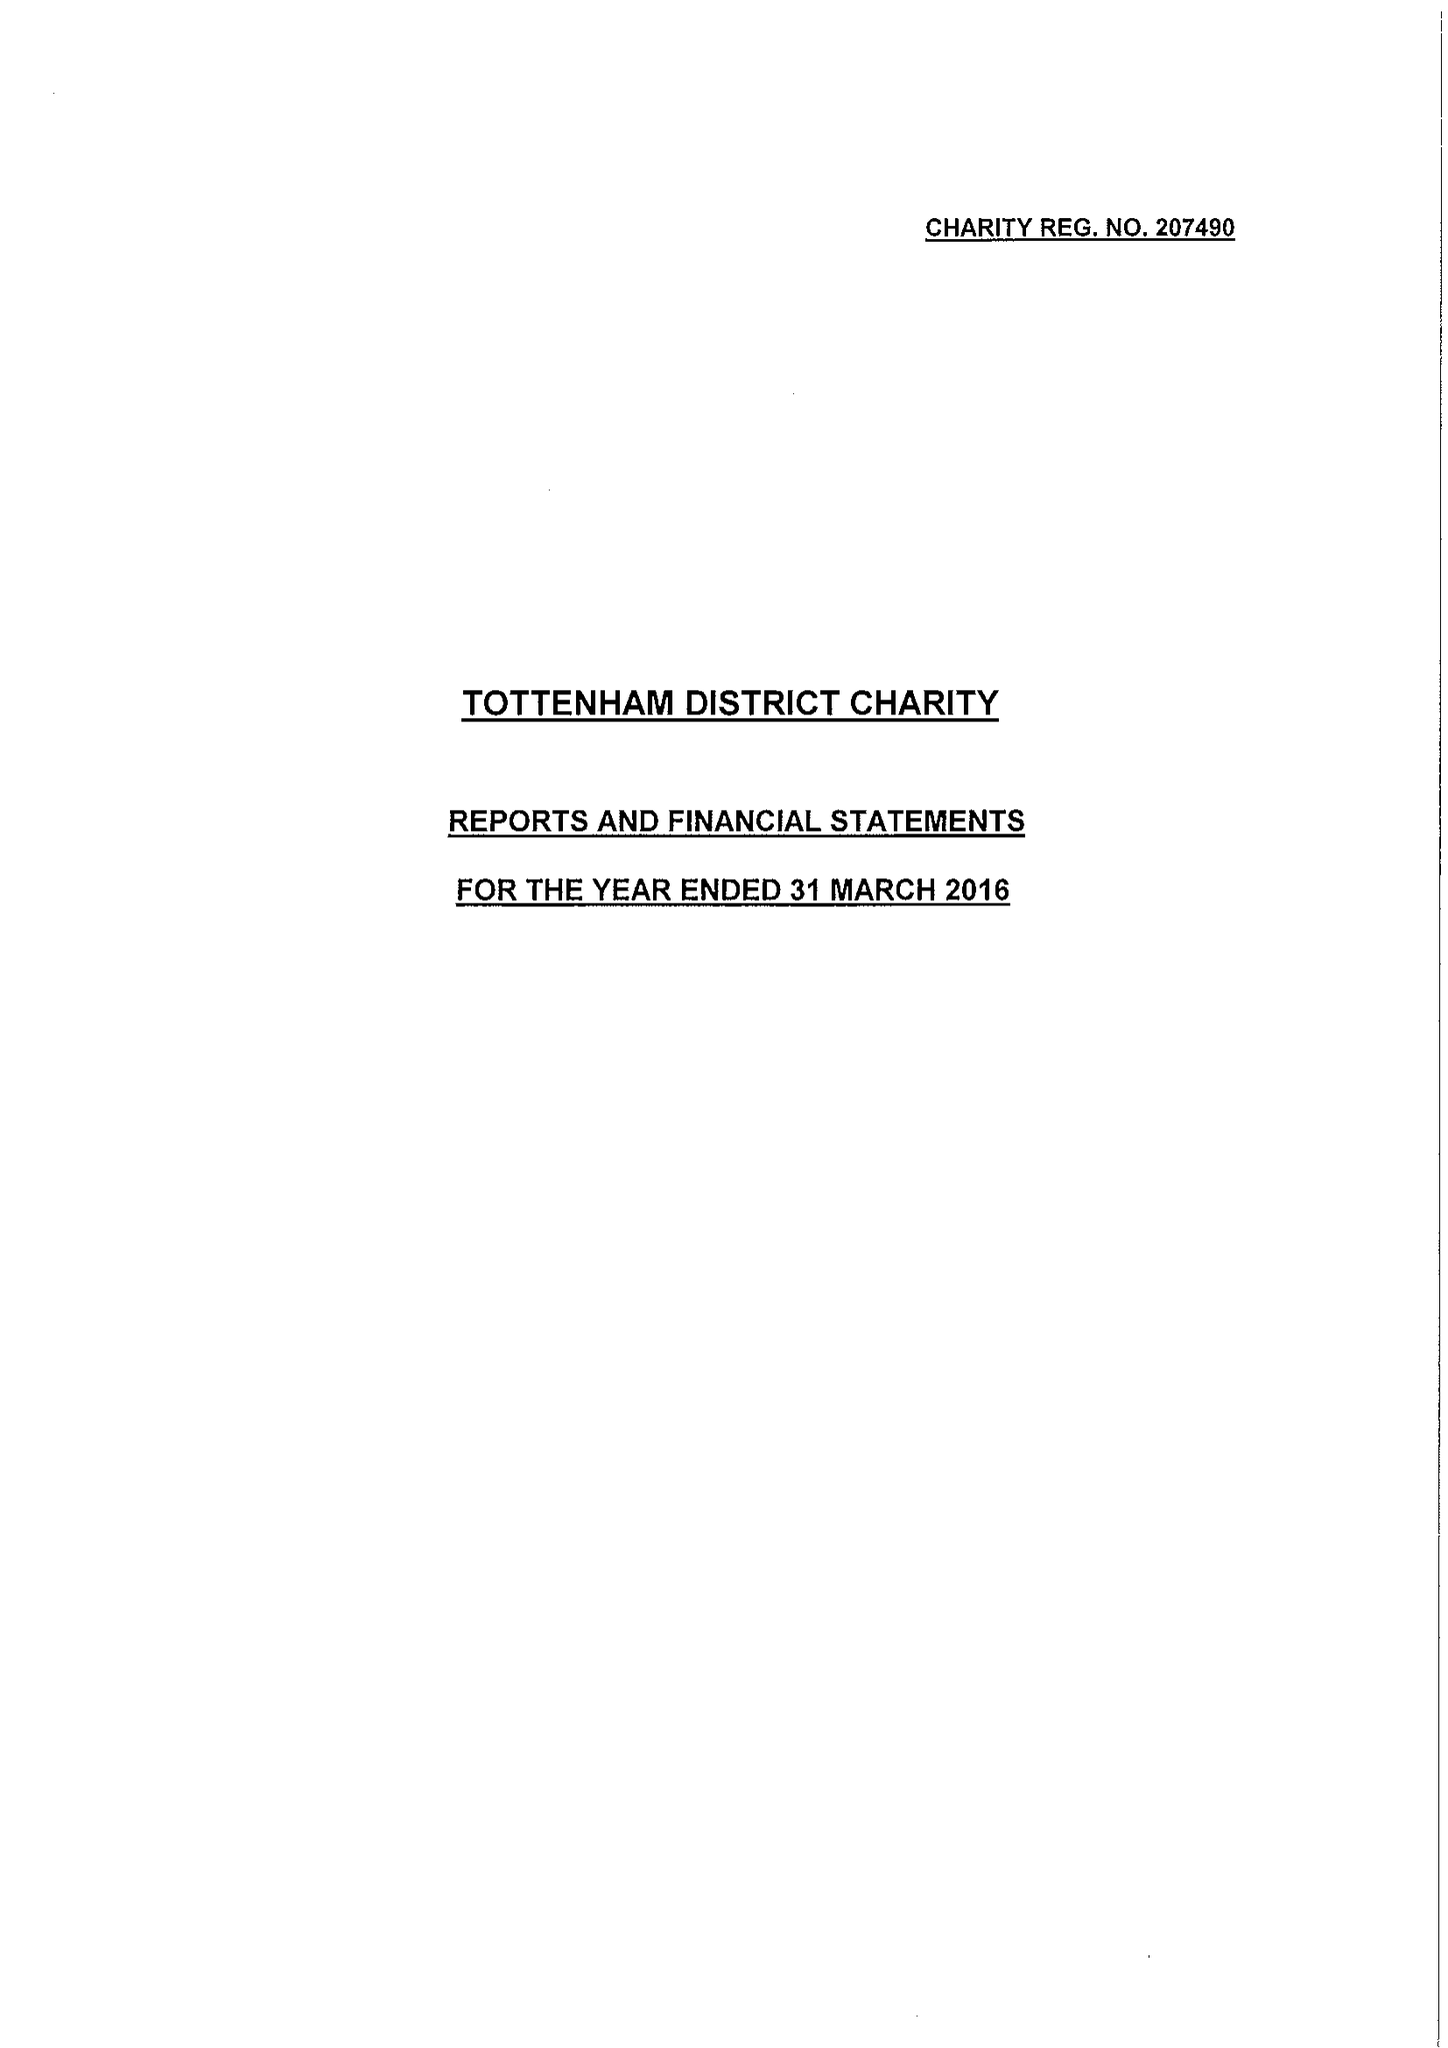What is the value for the report_date?
Answer the question using a single word or phrase. 2016-03-31 